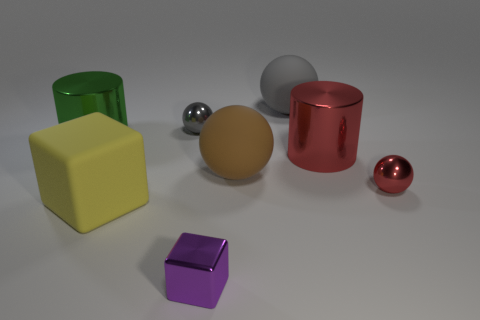What is the material of the small object that is both on the left side of the gray matte thing and in front of the green metal cylinder?
Provide a succinct answer. Metal. How many tiny red metal things are in front of the brown object?
Provide a succinct answer. 1. What number of gray rubber things are there?
Your response must be concise. 1. Is the size of the gray metal sphere the same as the metallic cube?
Your answer should be very brief. Yes. There is a metallic ball behind the big cylinder in front of the green shiny thing; is there a big rubber object that is behind it?
Provide a succinct answer. Yes. There is a purple thing that is the same shape as the yellow matte object; what is its material?
Your answer should be compact. Metal. What color is the small thing that is in front of the large block?
Offer a very short reply. Purple. What size is the brown matte thing?
Your answer should be compact. Large. Does the matte cube have the same size as the gray thing left of the gray matte ball?
Provide a short and direct response. No. What color is the metallic sphere that is to the left of the cube that is in front of the matte thing to the left of the purple cube?
Your response must be concise. Gray. 